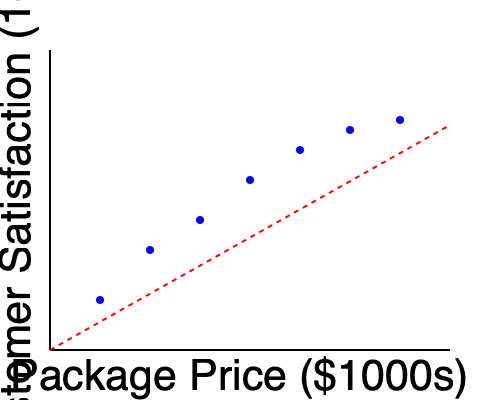Based on the scatter plot showing luxury travel package prices vs. customer satisfaction ratings, what can be inferred about the relationship between price and customer satisfaction? How might this information be useful for market forecasting in the luxury tourism industry? To answer this question, let's analyze the scatter plot step by step:

1. Observe the overall trend:
   The scatter plot shows a clear negative correlation between package price and customer satisfaction. As the price increases, customer satisfaction tends to decrease.

2. Analyze the slope:
   The red dashed line represents the general trend. Its negative slope indicates an inverse relationship between price and satisfaction.

3. Consider the strength of the relationship:
   The points are relatively close to the trend line, suggesting a moderately strong correlation.

4. Interpret the data points:
   - Lower-priced packages (left side of the graph) tend to have higher satisfaction ratings.
   - Higher-priced packages (right side of the graph) tend to have lower satisfaction ratings.

5. Market forecasting implications:
   a) Price sensitivity: Luxury travelers appear to be price-sensitive, with higher prices potentially leading to lower satisfaction.
   b) Value proposition: There may be a sweet spot where price and perceived value align optimally.
   c) Segmentation: Different price points might appeal to different customer segments with varying expectations.
   d) Product development: Focus on enhancing value perception for higher-priced packages to improve satisfaction.
   e) Pricing strategy: Consider the potential impact on satisfaction when setting prices for new packages.

6. Additional considerations:
   - Other factors not shown in the graph (e.g., destination, amenities) may influence satisfaction.
   - The relationship may not be purely linear; there could be diminishing returns or threshold effects.

This analysis can inform market forecasting by helping predict customer satisfaction for different price points and guiding pricing and product development strategies to optimize customer satisfaction and potentially increase market share in the luxury tourism industry.
Answer: Negative correlation between price and satisfaction; useful for optimizing pricing, product development, and market segmentation strategies. 